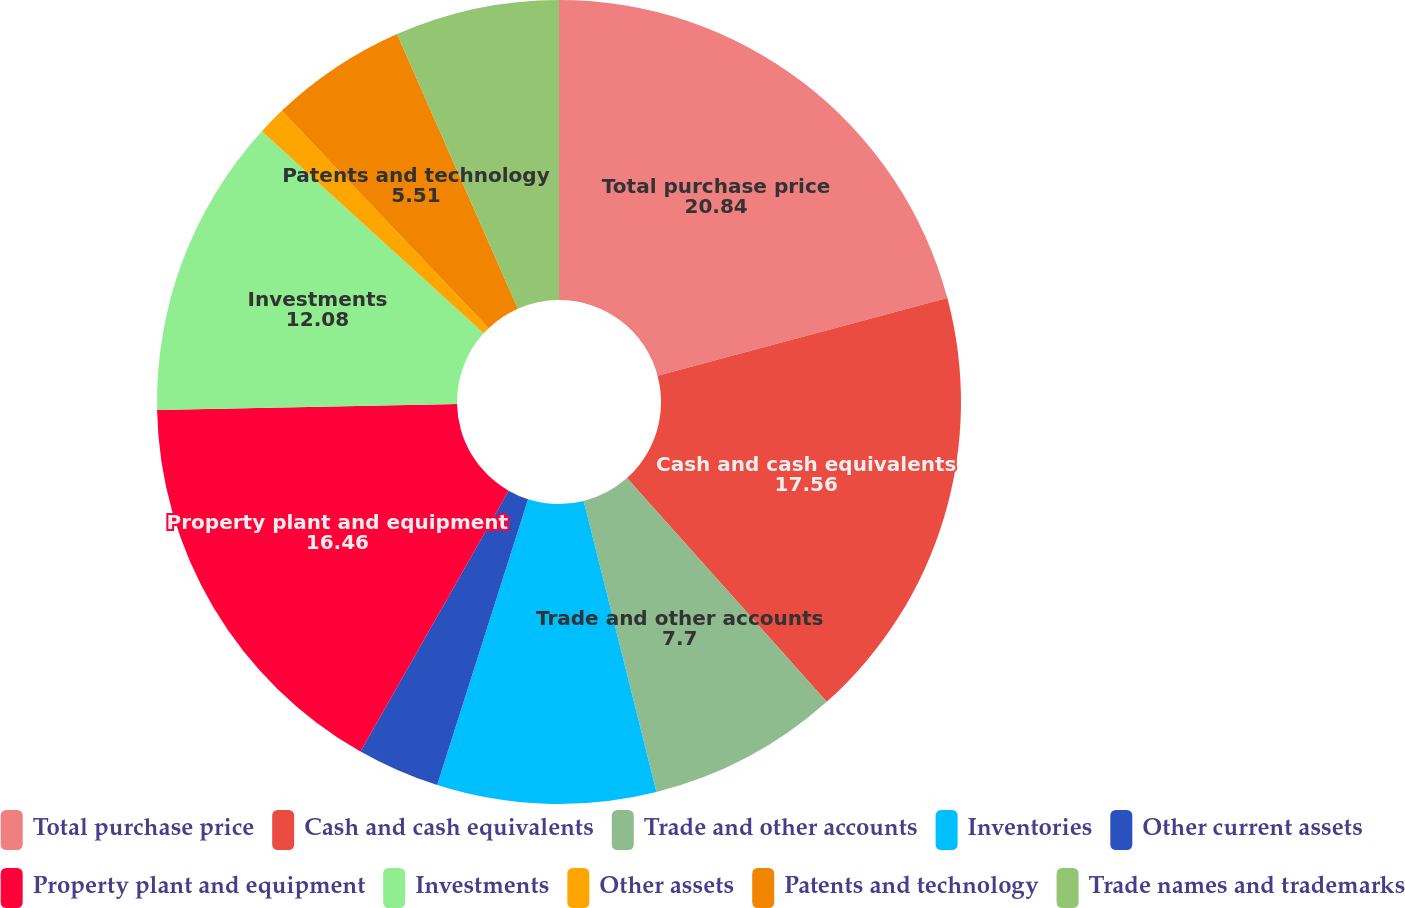Convert chart to OTSL. <chart><loc_0><loc_0><loc_500><loc_500><pie_chart><fcel>Total purchase price<fcel>Cash and cash equivalents<fcel>Trade and other accounts<fcel>Inventories<fcel>Other current assets<fcel>Property plant and equipment<fcel>Investments<fcel>Other assets<fcel>Patents and technology<fcel>Trade names and trademarks<nl><fcel>20.84%<fcel>17.56%<fcel>7.7%<fcel>8.8%<fcel>3.32%<fcel>16.46%<fcel>12.08%<fcel>1.13%<fcel>5.51%<fcel>6.6%<nl></chart> 